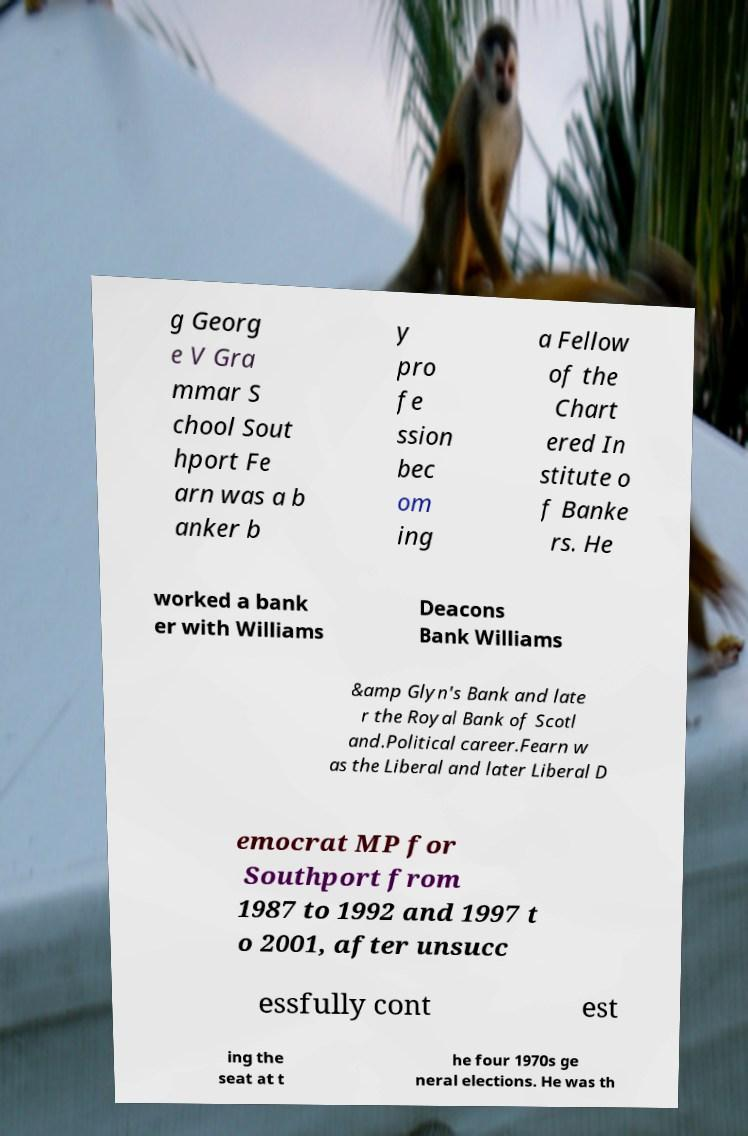Can you accurately transcribe the text from the provided image for me? g Georg e V Gra mmar S chool Sout hport Fe arn was a b anker b y pro fe ssion bec om ing a Fellow of the Chart ered In stitute o f Banke rs. He worked a bank er with Williams Deacons Bank Williams &amp Glyn's Bank and late r the Royal Bank of Scotl and.Political career.Fearn w as the Liberal and later Liberal D emocrat MP for Southport from 1987 to 1992 and 1997 t o 2001, after unsucc essfully cont est ing the seat at t he four 1970s ge neral elections. He was th 